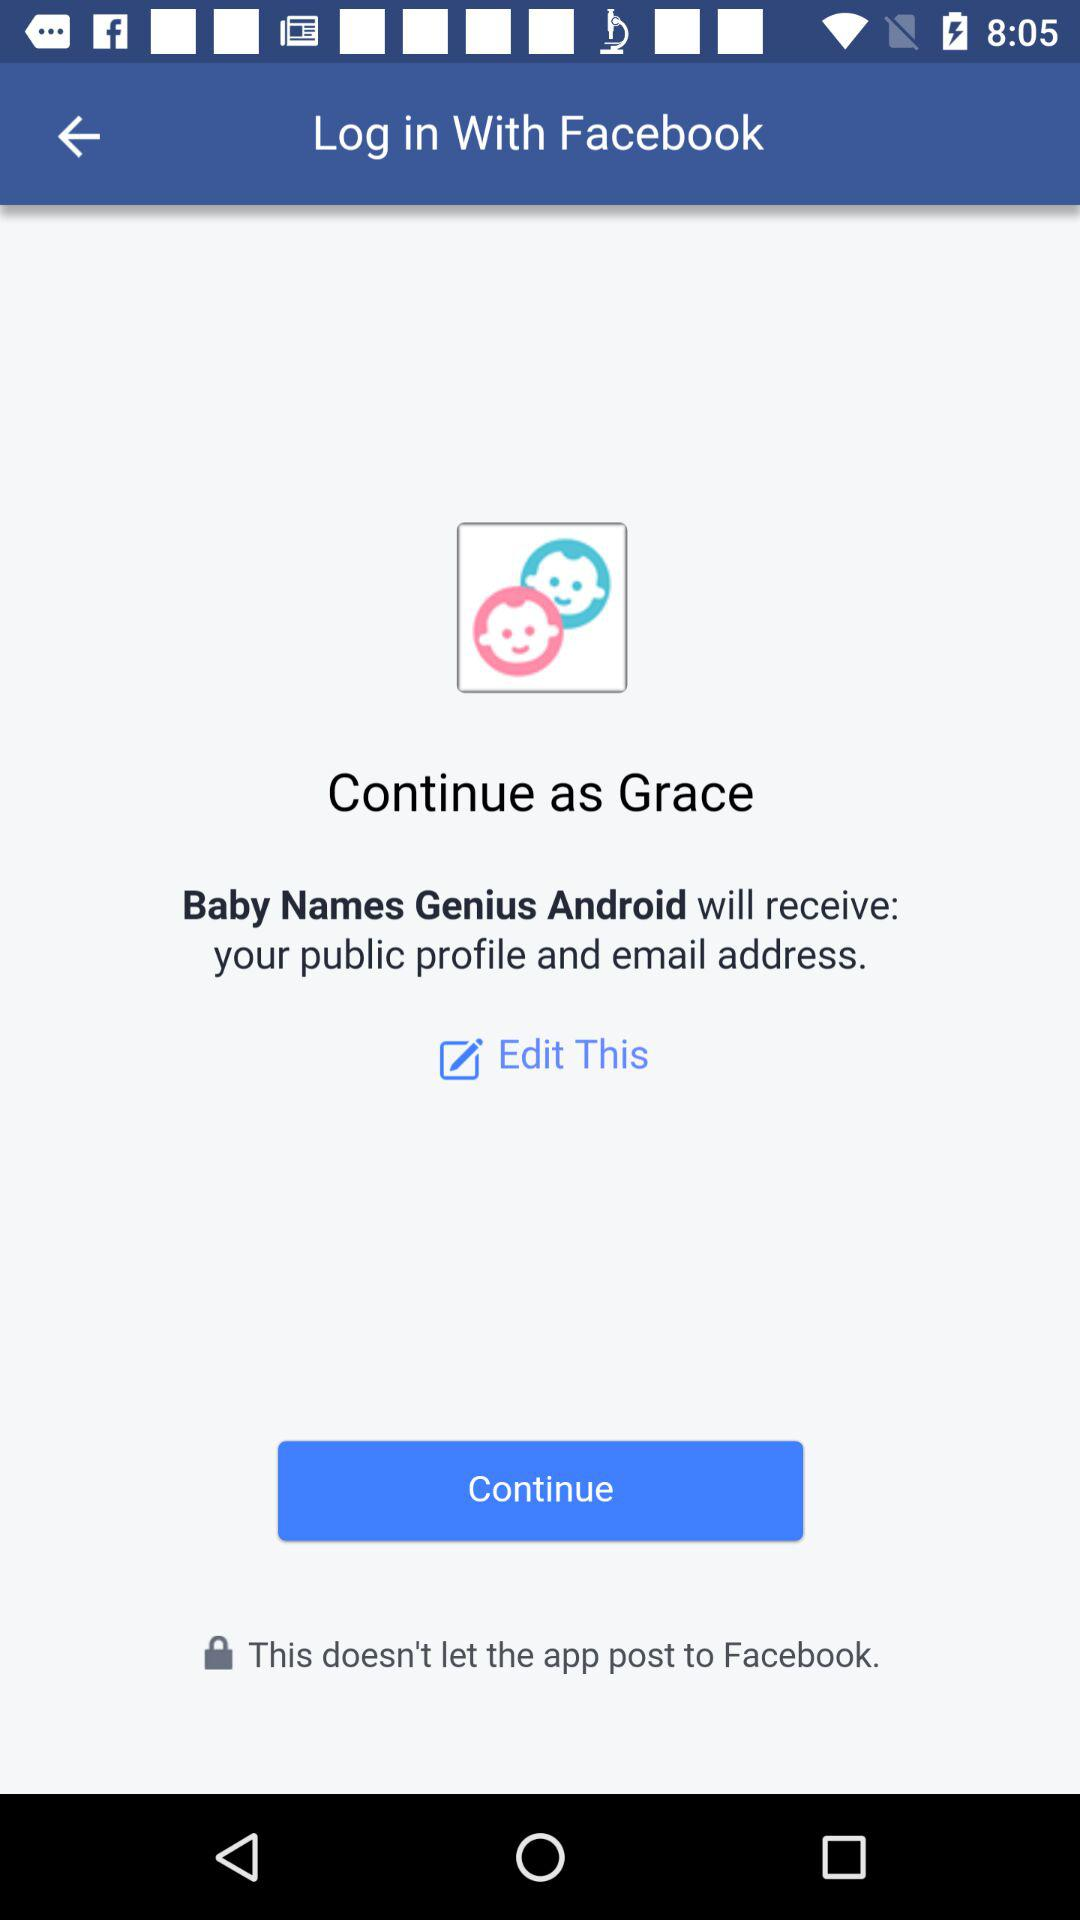What is the login name? The login name is Grace. 